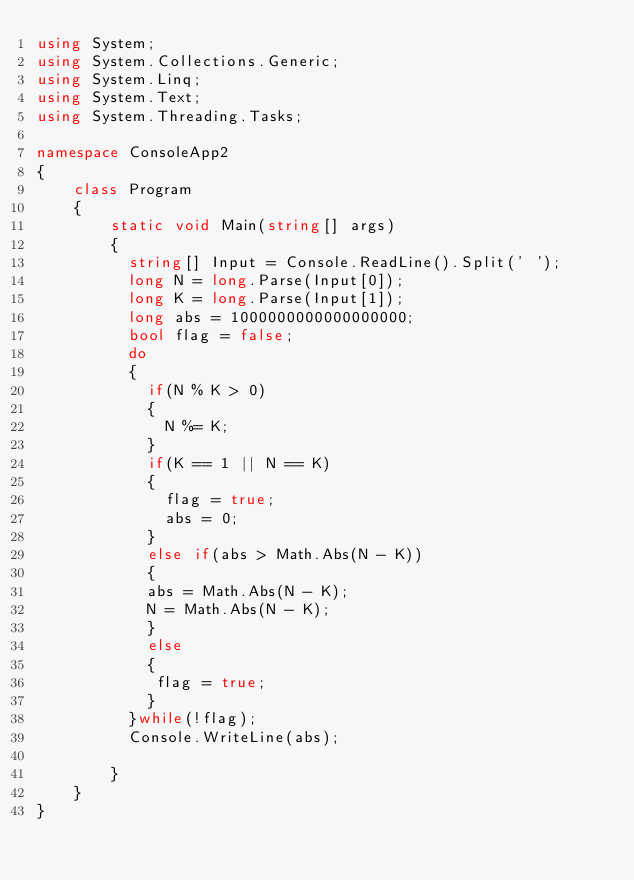<code> <loc_0><loc_0><loc_500><loc_500><_C#_>using System;
using System.Collections.Generic;
using System.Linq;
using System.Text;
using System.Threading.Tasks;

namespace ConsoleApp2
{
    class Program
    {
        static void Main(string[] args)
        {
          string[] Input = Console.ReadLine().Split(' ');
          long N = long.Parse(Input[0]);
          long K = long.Parse(Input[1]);
          long abs = 1000000000000000000;
          bool flag = false;
          do
          {
            if(N % K > 0)
            {
              N %= K;
            }
            if(K == 1 || N == K)
            {
              flag = true;
              abs = 0;
            }
            else if(abs > Math.Abs(N - K))
            {
          	abs = Math.Abs(N - K);
            N = Math.Abs(N - K);
            }
            else
            {
             flag = true; 
            }
          }while(!flag);
          Console.WriteLine(abs);
          
        }
    }
}
</code> 